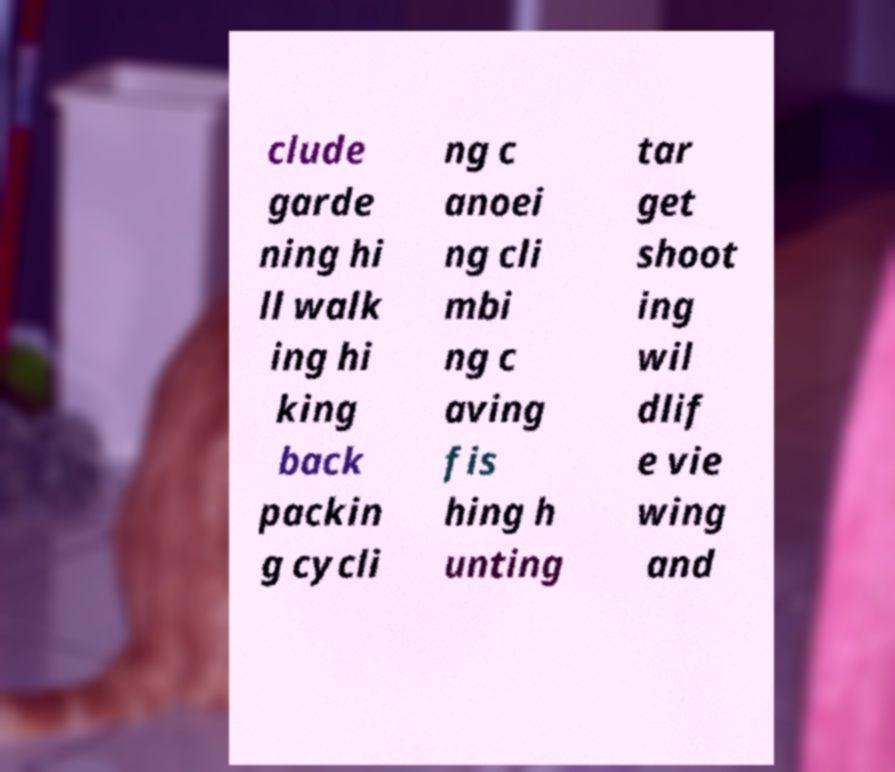Please identify and transcribe the text found in this image. clude garde ning hi ll walk ing hi king back packin g cycli ng c anoei ng cli mbi ng c aving fis hing h unting tar get shoot ing wil dlif e vie wing and 